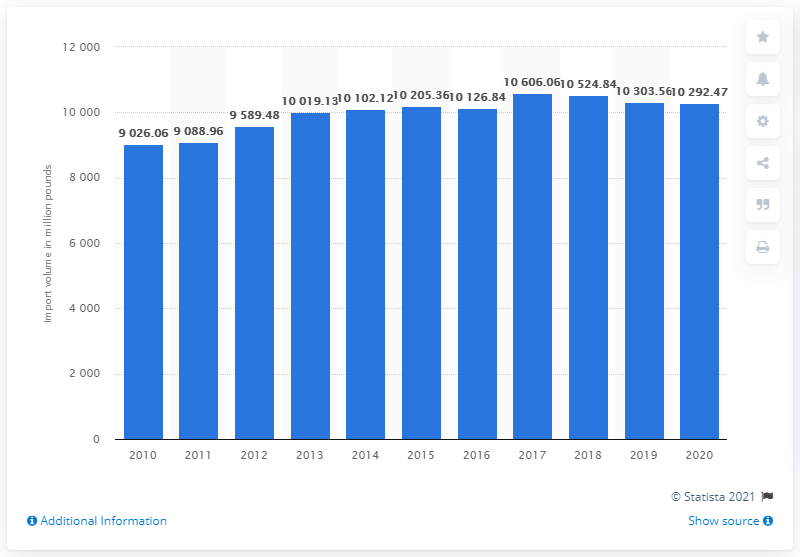Draw attention to some important aspects in this diagram. In 2020, a total of 10,292.47 pounds of bananas were imported to the United States. 